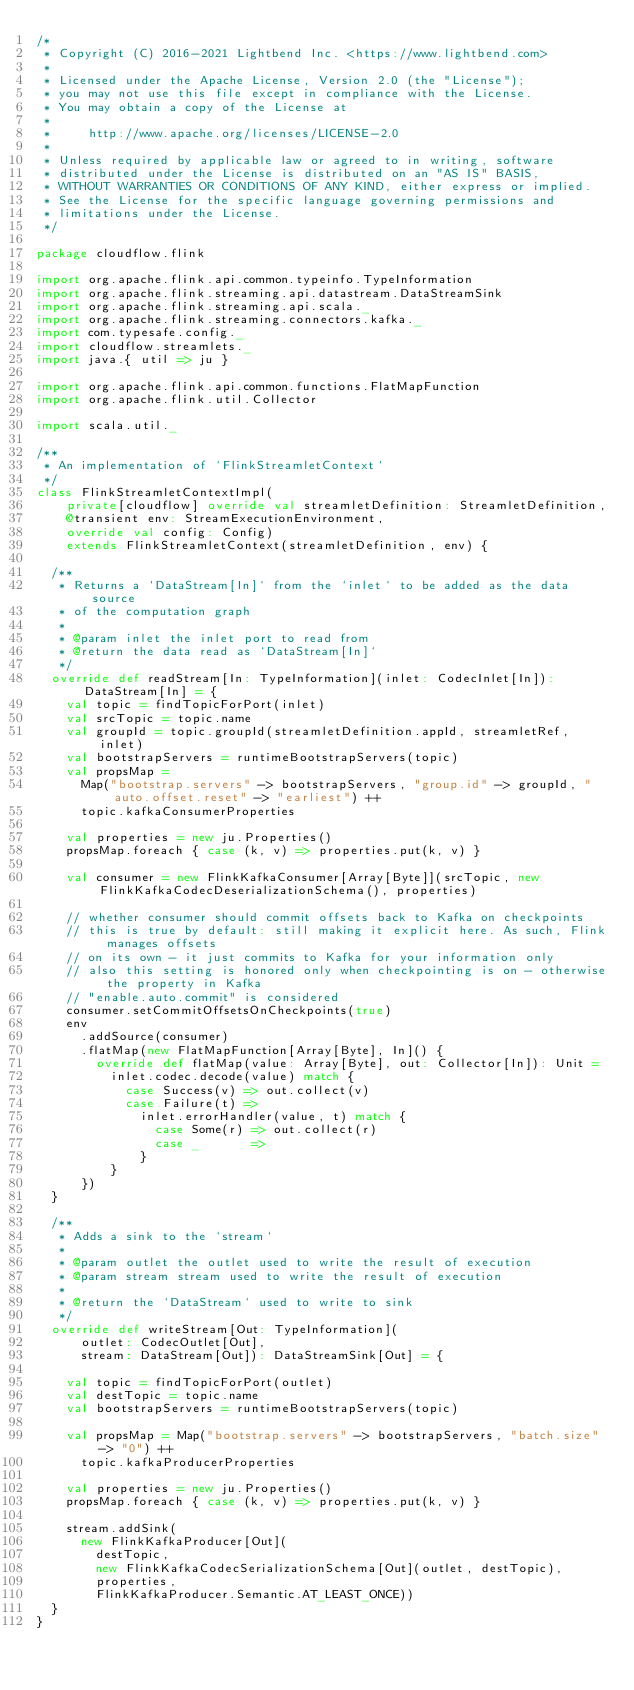<code> <loc_0><loc_0><loc_500><loc_500><_Scala_>/*
 * Copyright (C) 2016-2021 Lightbend Inc. <https://www.lightbend.com>
 *
 * Licensed under the Apache License, Version 2.0 (the "License");
 * you may not use this file except in compliance with the License.
 * You may obtain a copy of the License at
 *
 *     http://www.apache.org/licenses/LICENSE-2.0
 *
 * Unless required by applicable law or agreed to in writing, software
 * distributed under the License is distributed on an "AS IS" BASIS,
 * WITHOUT WARRANTIES OR CONDITIONS OF ANY KIND, either express or implied.
 * See the License for the specific language governing permissions and
 * limitations under the License.
 */

package cloudflow.flink

import org.apache.flink.api.common.typeinfo.TypeInformation
import org.apache.flink.streaming.api.datastream.DataStreamSink
import org.apache.flink.streaming.api.scala._
import org.apache.flink.streaming.connectors.kafka._
import com.typesafe.config._
import cloudflow.streamlets._
import java.{ util => ju }

import org.apache.flink.api.common.functions.FlatMapFunction
import org.apache.flink.util.Collector

import scala.util._

/**
 * An implementation of `FlinkStreamletContext`
 */
class FlinkStreamletContextImpl(
    private[cloudflow] override val streamletDefinition: StreamletDefinition,
    @transient env: StreamExecutionEnvironment,
    override val config: Config)
    extends FlinkStreamletContext(streamletDefinition, env) {

  /**
   * Returns a `DataStream[In]` from the `inlet` to be added as the data source
   * of the computation graph
   *
   * @param inlet the inlet port to read from
   * @return the data read as `DataStream[In]`
   */
  override def readStream[In: TypeInformation](inlet: CodecInlet[In]): DataStream[In] = {
    val topic = findTopicForPort(inlet)
    val srcTopic = topic.name
    val groupId = topic.groupId(streamletDefinition.appId, streamletRef, inlet)
    val bootstrapServers = runtimeBootstrapServers(topic)
    val propsMap =
      Map("bootstrap.servers" -> bootstrapServers, "group.id" -> groupId, "auto.offset.reset" -> "earliest") ++
      topic.kafkaConsumerProperties

    val properties = new ju.Properties()
    propsMap.foreach { case (k, v) => properties.put(k, v) }

    val consumer = new FlinkKafkaConsumer[Array[Byte]](srcTopic, new FlinkKafkaCodecDeserializationSchema(), properties)

    // whether consumer should commit offsets back to Kafka on checkpoints
    // this is true by default: still making it explicit here. As such, Flink manages offsets
    // on its own - it just commits to Kafka for your information only
    // also this setting is honored only when checkpointing is on - otherwise the property in Kafka
    // "enable.auto.commit" is considered
    consumer.setCommitOffsetsOnCheckpoints(true)
    env
      .addSource(consumer)
      .flatMap(new FlatMapFunction[Array[Byte], In]() {
        override def flatMap(value: Array[Byte], out: Collector[In]): Unit =
          inlet.codec.decode(value) match {
            case Success(v) => out.collect(v)
            case Failure(t) =>
              inlet.errorHandler(value, t) match {
                case Some(r) => out.collect(r)
                case _       =>
              }
          }
      })
  }

  /**
   * Adds a sink to the `stream`
   *
   * @param outlet the outlet used to write the result of execution
   * @param stream stream used to write the result of execution
   *
   * @return the `DataStream` used to write to sink
   */
  override def writeStream[Out: TypeInformation](
      outlet: CodecOutlet[Out],
      stream: DataStream[Out]): DataStreamSink[Out] = {

    val topic = findTopicForPort(outlet)
    val destTopic = topic.name
    val bootstrapServers = runtimeBootstrapServers(topic)

    val propsMap = Map("bootstrap.servers" -> bootstrapServers, "batch.size" -> "0") ++
      topic.kafkaProducerProperties

    val properties = new ju.Properties()
    propsMap.foreach { case (k, v) => properties.put(k, v) }

    stream.addSink(
      new FlinkKafkaProducer[Out](
        destTopic,
        new FlinkKafkaCodecSerializationSchema[Out](outlet, destTopic),
        properties,
        FlinkKafkaProducer.Semantic.AT_LEAST_ONCE))
  }
}
</code> 